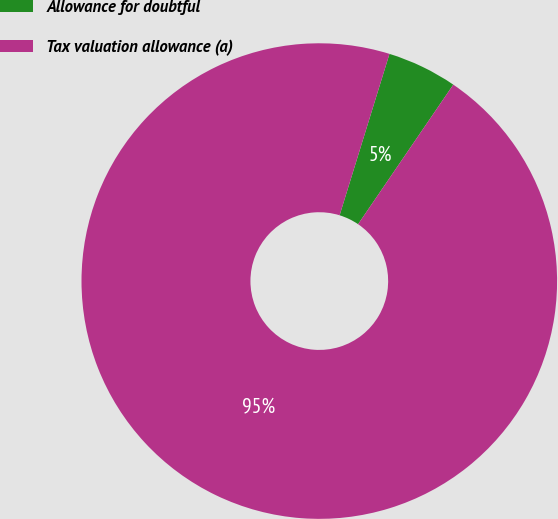Convert chart. <chart><loc_0><loc_0><loc_500><loc_500><pie_chart><fcel>Allowance for doubtful<fcel>Tax valuation allowance (a)<nl><fcel>4.76%<fcel>95.24%<nl></chart> 